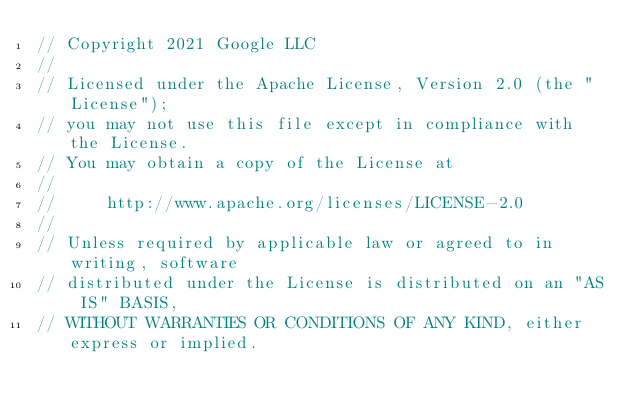<code> <loc_0><loc_0><loc_500><loc_500><_Go_>// Copyright 2021 Google LLC
//
// Licensed under the Apache License, Version 2.0 (the "License");
// you may not use this file except in compliance with the License.
// You may obtain a copy of the License at
//
//     http://www.apache.org/licenses/LICENSE-2.0
//
// Unless required by applicable law or agreed to in writing, software
// distributed under the License is distributed on an "AS IS" BASIS,
// WITHOUT WARRANTIES OR CONDITIONS OF ANY KIND, either express or implied.</code> 